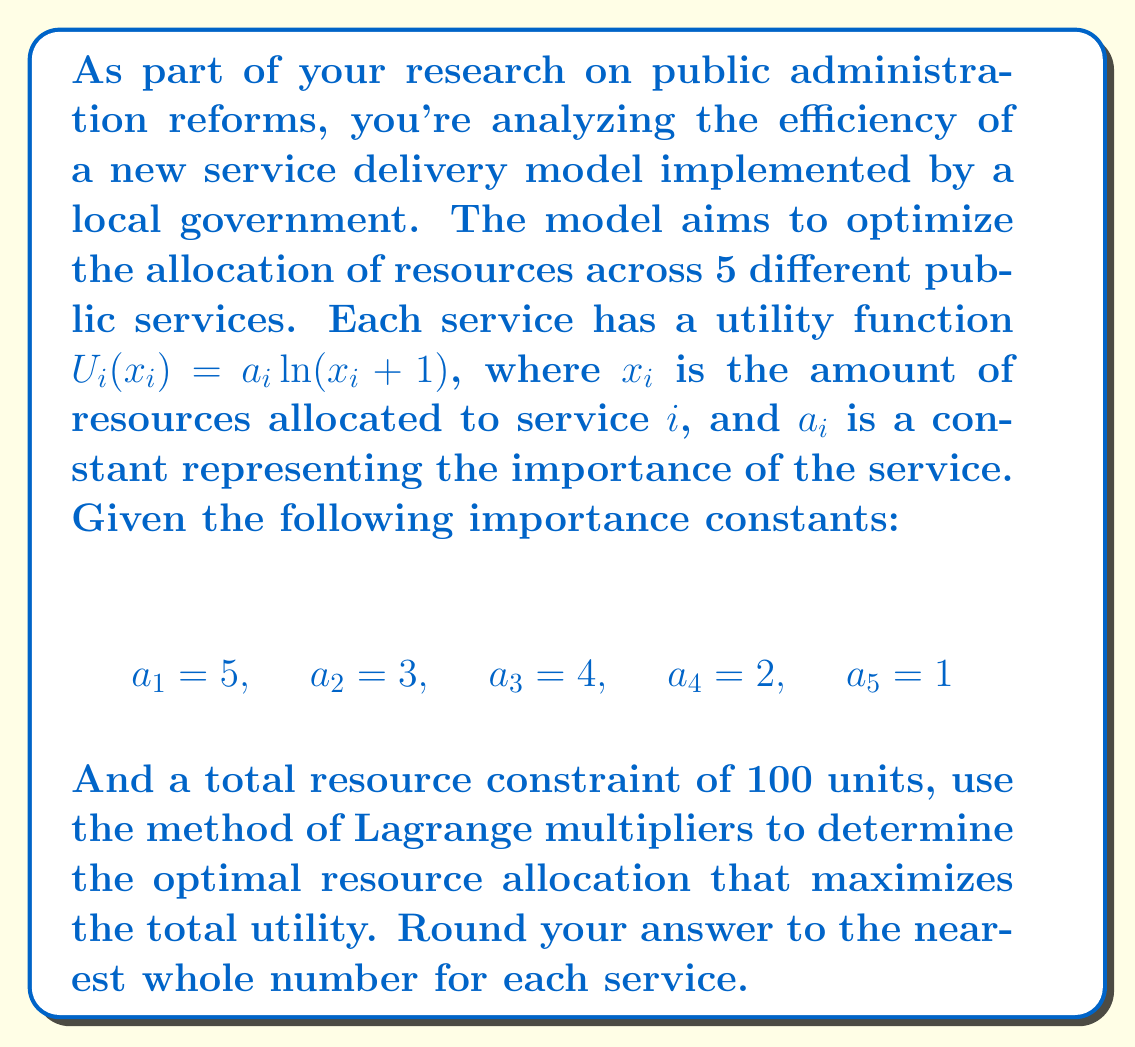Can you solve this math problem? To solve this optimization problem, we'll use the method of Lagrange multipliers. Let's approach this step-by-step:

1) The objective function (total utility) is:

   $$U = \sum_{i=1}^5 U_i(x_i) = \sum_{i=1}^5 a_i \ln(x_i + 1)$$

2) The constraint is:

   $$\sum_{i=1}^5 x_i = 100$$

3) We form the Lagrangian:

   $$L = \sum_{i=1}^5 a_i \ln(x_i + 1) - \lambda(\sum_{i=1}^5 x_i - 100)$$

4) We take partial derivatives and set them to zero:

   $$\frac{\partial L}{\partial x_i} = \frac{a_i}{x_i + 1} - \lambda = 0$$
   $$\frac{\partial L}{\partial \lambda} = \sum_{i=1}^5 x_i - 100 = 0$$

5) From the first equation, we get:

   $$x_i = \frac{a_i}{\lambda} - 1$$

6) Substituting this into the constraint equation:

   $$\sum_{i=1}^5 (\frac{a_i}{\lambda} - 1) = 100$$
   $$\frac{1}{\lambda}\sum_{i=1}^5 a_i - 5 = 100$$
   $$\frac{1}{\lambda}(5+3+4+2+1) - 5 = 100$$
   $$\frac{15}{\lambda} = 105$$
   $$\lambda = \frac{1}{7}$$

7) Now we can calculate each $x_i$:

   $$x_1 = 7 \cdot 5 - 1 = 34$$
   $$x_2 = 7 \cdot 3 - 1 = 20$$
   $$x_3 = 7 \cdot 4 - 1 = 27$$
   $$x_4 = 7 \cdot 2 - 1 = 13$$
   $$x_5 = 7 \cdot 1 - 1 = 6$$

8) Rounding to the nearest whole number:

   $x_1 = 34$, $x_2 = 20$, $x_3 = 27$, $x_4 = 13$, $x_5 = 6$
Answer: The optimal resource allocation (rounded to the nearest whole number) is:
Service 1: 34 units
Service 2: 20 units
Service 3: 27 units
Service 4: 13 units
Service 5: 6 units 